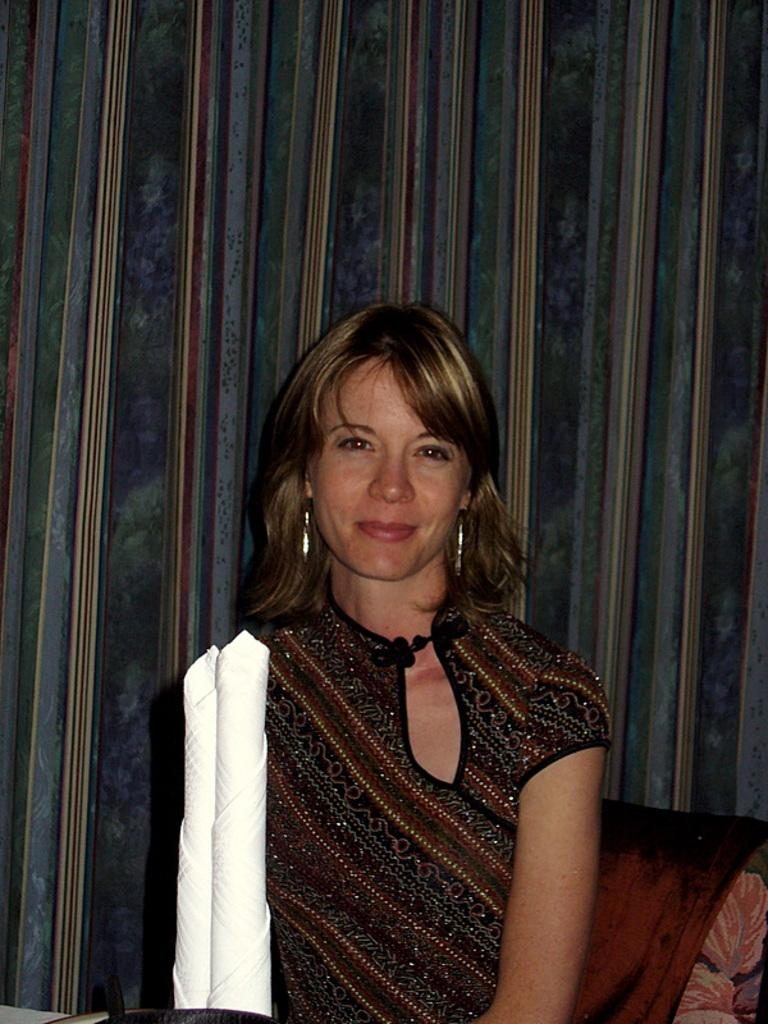Who is present in the image? There is a woman in the image. What is the woman wearing? The woman is wearing earrings and a black dress. What is the woman's facial expression? The woman is smiling. What is the woman sitting on in the image? The woman is sitting on a couch. What can be seen in the background of the image? There is a cloth visible in the background. What time of day is it in the image, based on the woman's smile? The woman's smile does not indicate the time of day; it only shows her emotional state. 